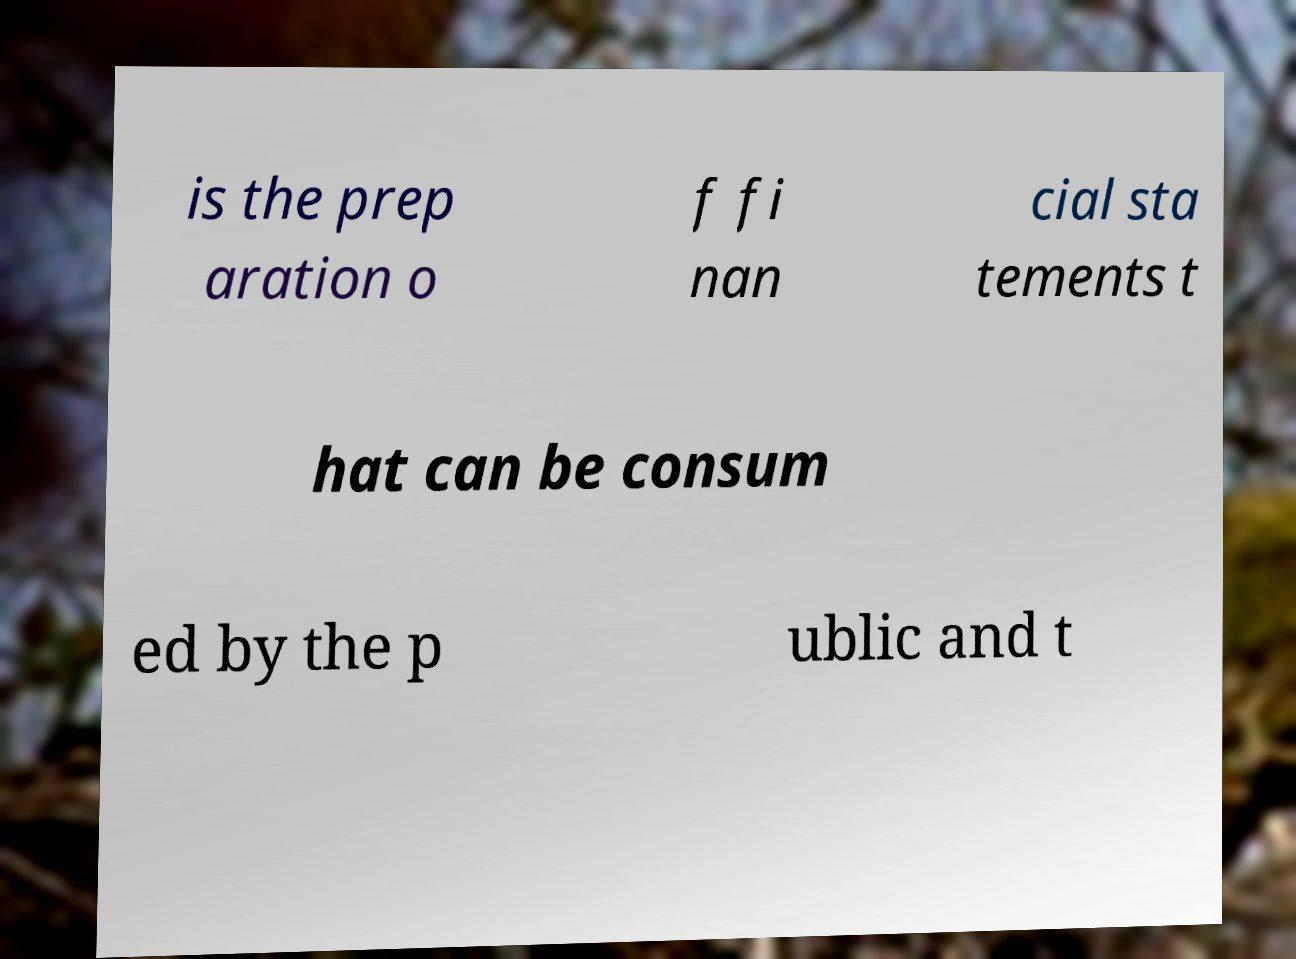Please read and relay the text visible in this image. What does it say? is the prep aration o f fi nan cial sta tements t hat can be consum ed by the p ublic and t 